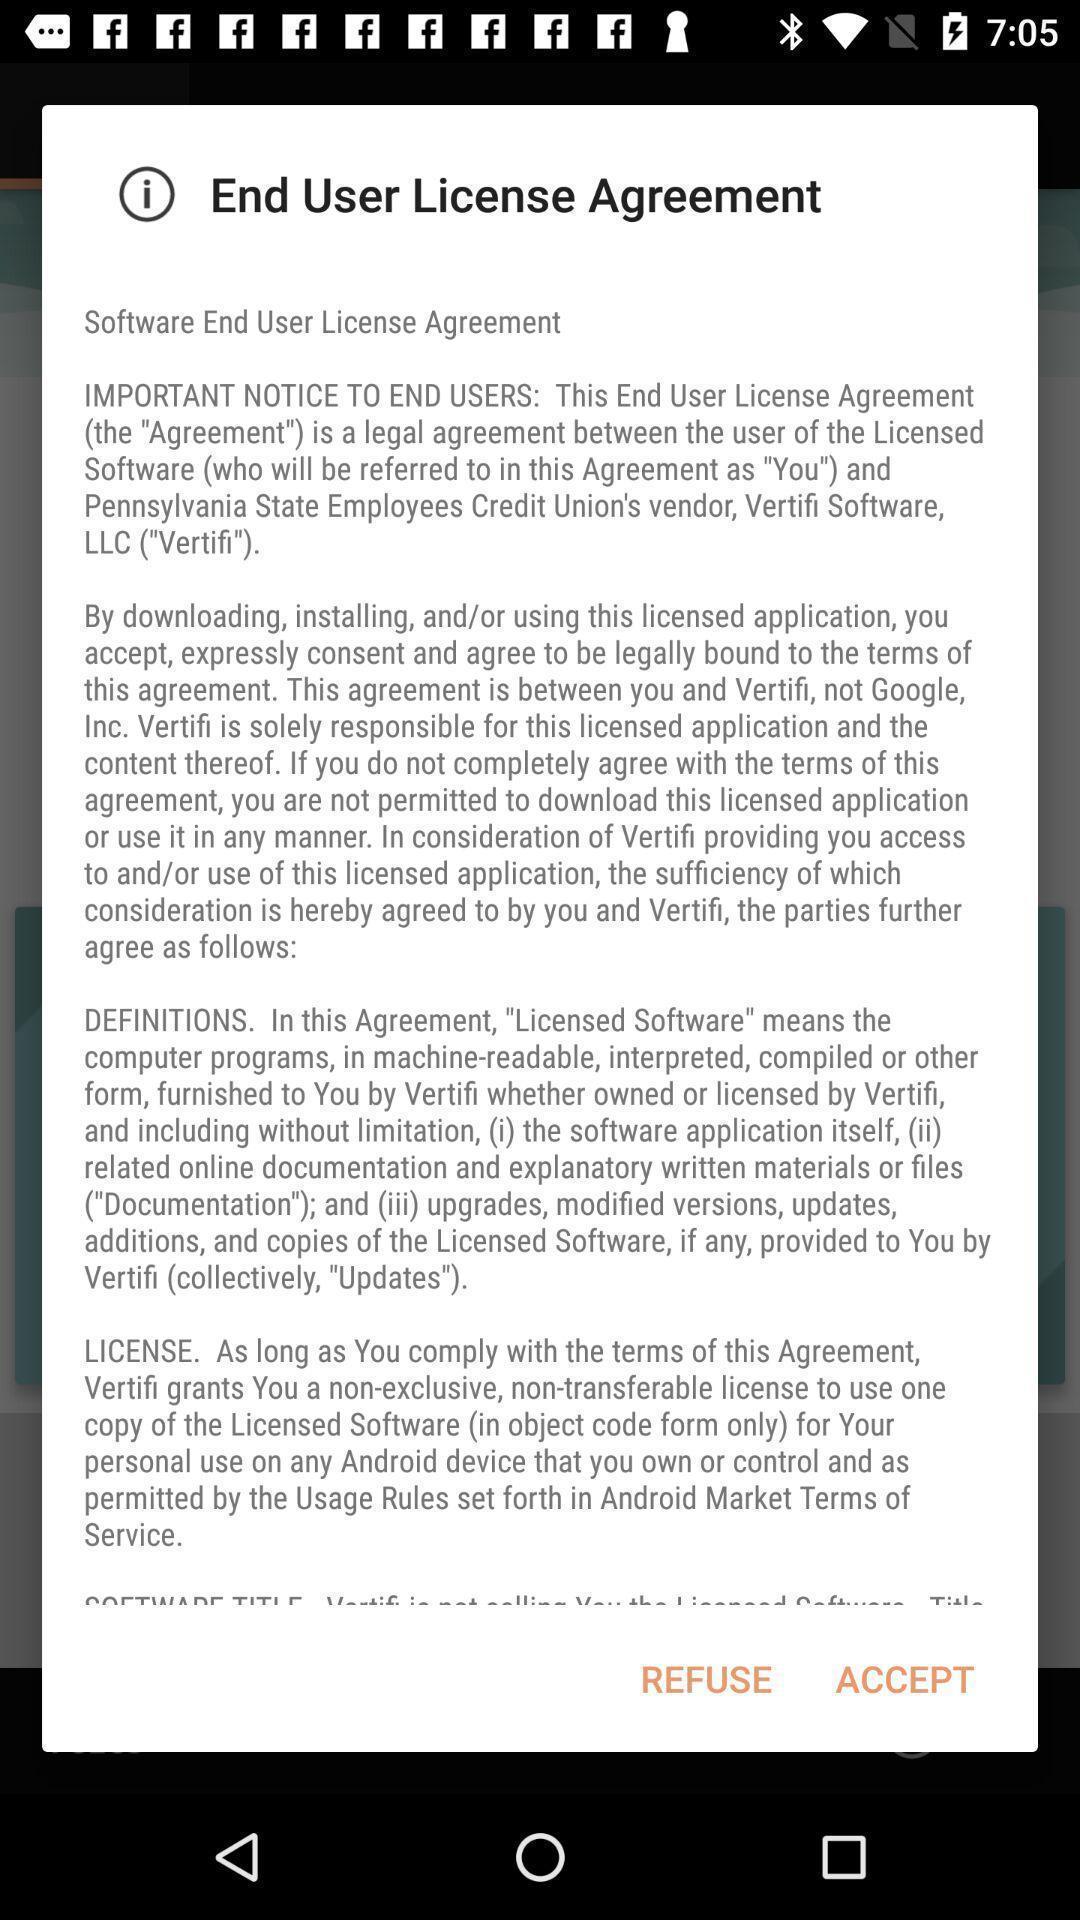Describe the content in this image. Pop-up to give confirmation for an agreement. 